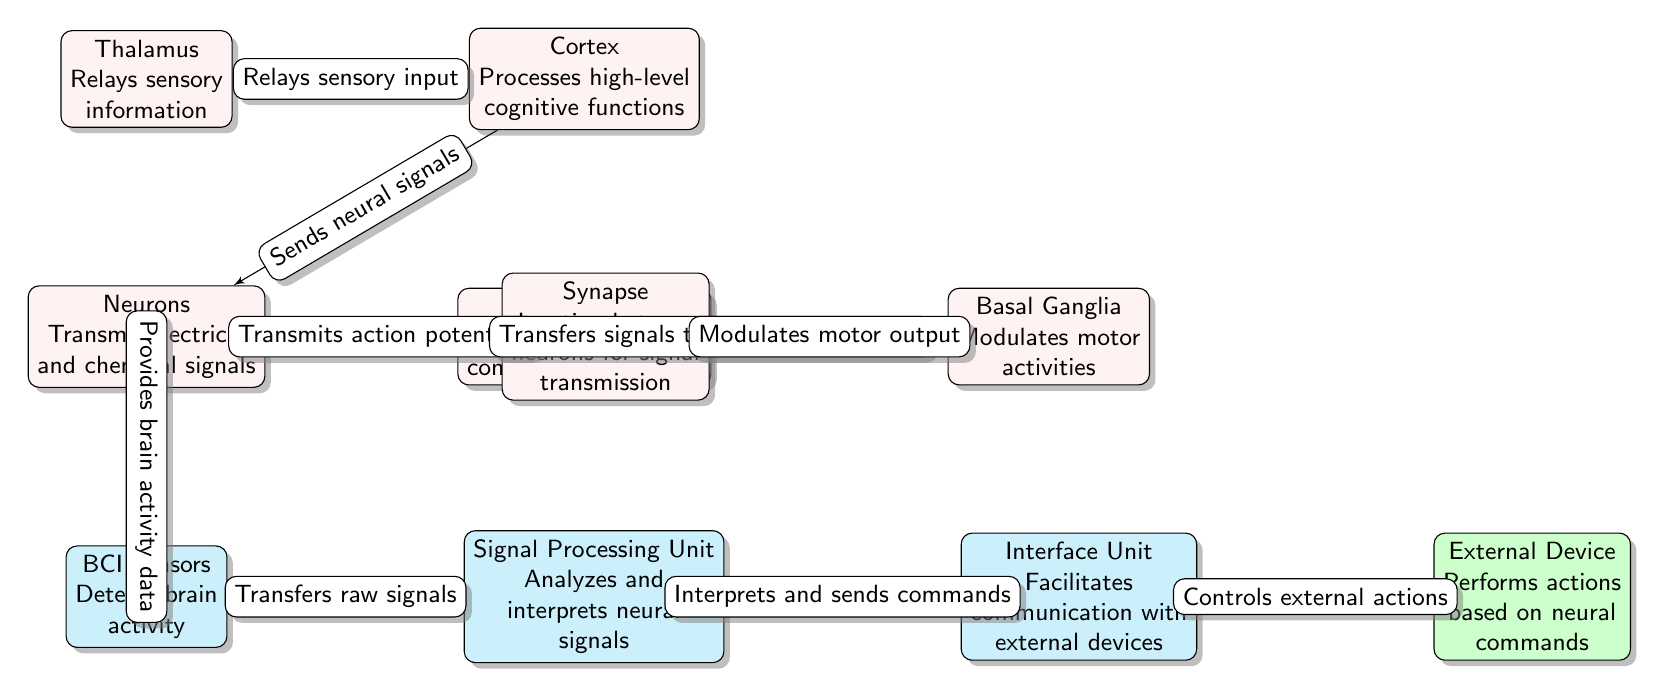What is the function of the Cortex? The Cortex processes high-level cognitive functions according to the label in the node.
Answer: Processes high-level cognitive functions How many brain nodes are present in the diagram? The diagram includes five brain nodes: Cortex, Motor Cortex, Basal Ganglia, Thalamus, and Neurons.
Answer: Five Which node sends neural signals to Neurons? The arrow from Cortex to Neurons indicates that the Cortex sends neural signals to this node.
Answer: Cortex What is the role of the Signal Processing Unit? The Signal Processing Unit analyzes and interprets neural signals as described in the node.
Answer: Analyzes and interprets neural signals How does the Thalamus interact with the Cortex? The Thalamus relays sensory information to the Cortex as indicated by the directed edge between them.
Answer: Relays sensory information What does the Interface Unit do? The Interface Unit facilitates communication with external devices according to the information provided in the node.
Answer: Facilitates communication with external devices What type of information does the BCI Sensors node provide? BCI Sensors provide brain activity data as indicated by the label in the node.
Answer: Brain activity data Which brain structure modulates motor activities? The Basal Ganglia modulates motor activities as specified in the node label.
Answer: Basal Ganglia What is the outcome of the connection from Interface Unit to External Device? The connection shows that the Interface Unit controls external actions based on the neural commands it receives.
Answer: Controls external actions 